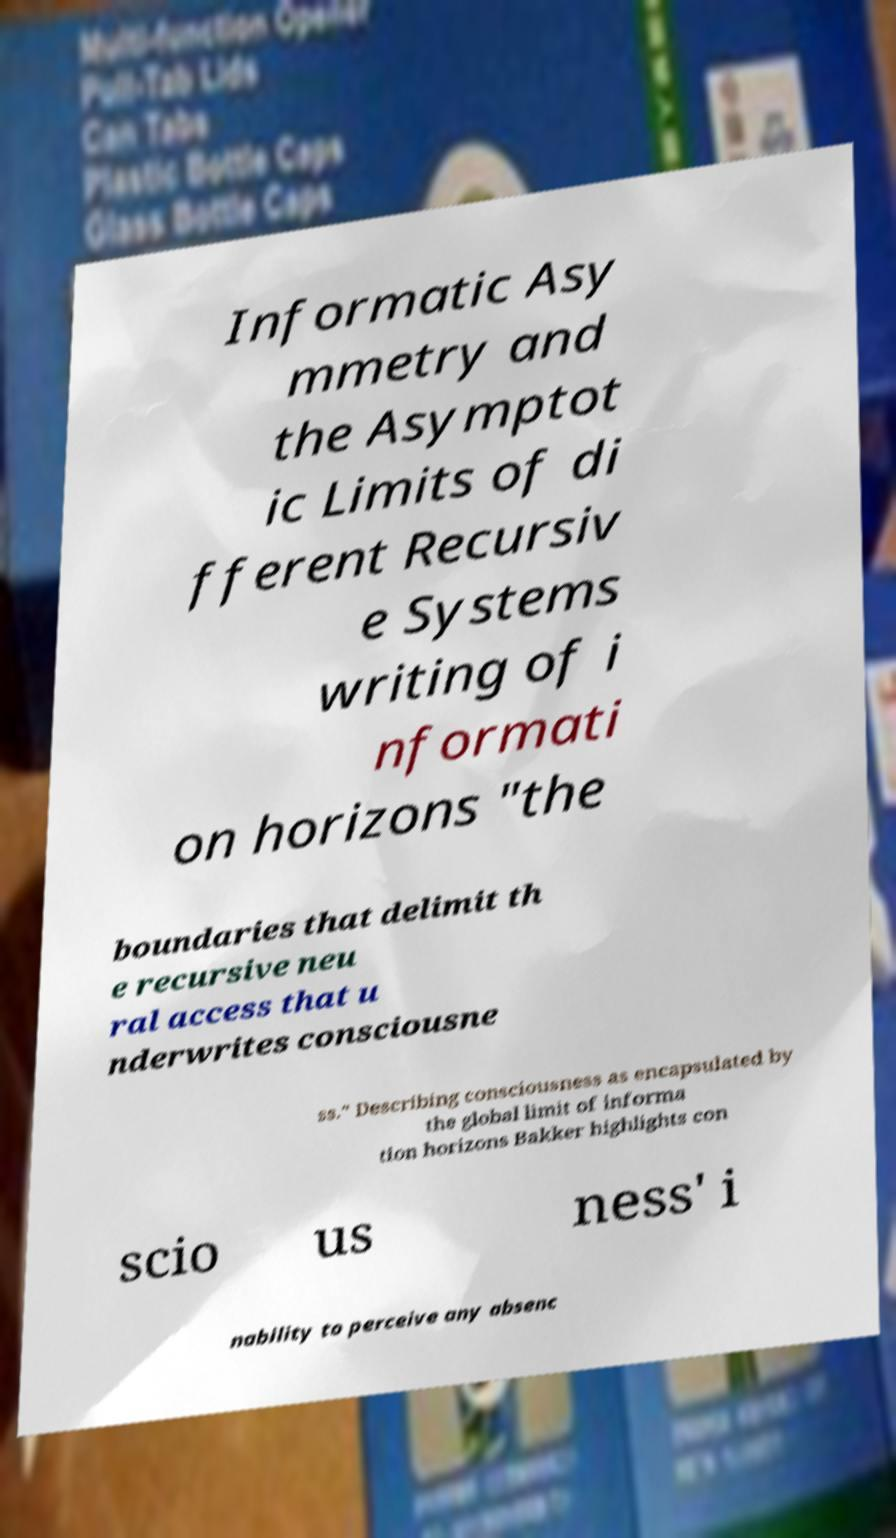Please identify and transcribe the text found in this image. Informatic Asy mmetry and the Asymptot ic Limits of di fferent Recursiv e Systems writing of i nformati on horizons "the boundaries that delimit th e recursive neu ral access that u nderwrites consciousne ss." Describing consciousness as encapsulated by the global limit of informa tion horizons Bakker highlights con scio us ness' i nability to perceive any absenc 